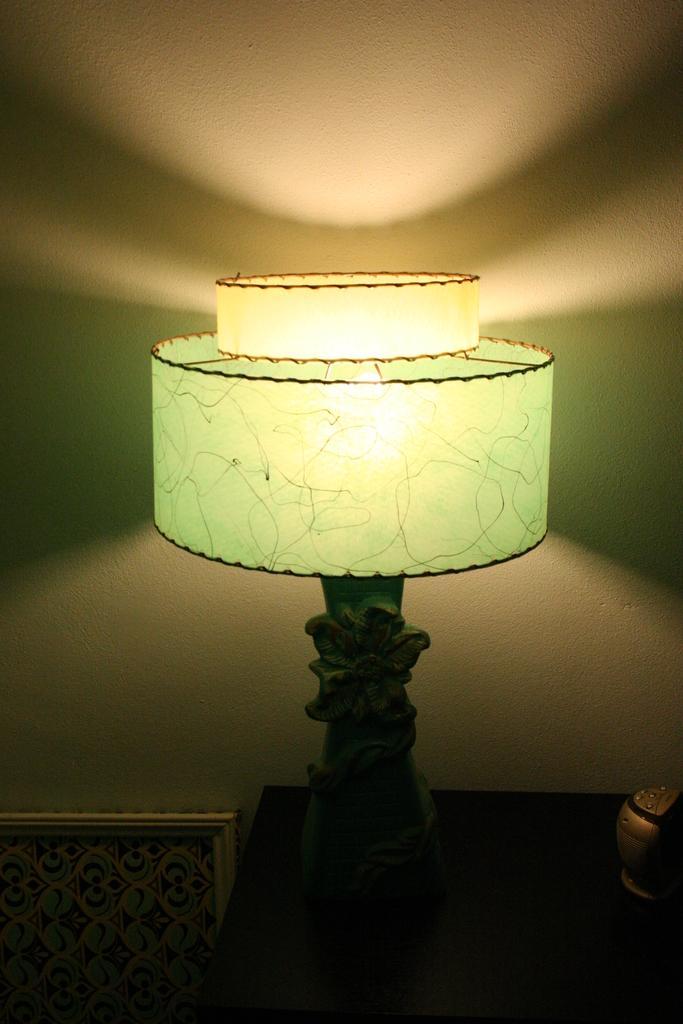In one or two sentences, can you explain what this image depicts? In this image we can see a lamp and a device placed on the table. In the left side of the image we can see a frame. At the top of the image we can see the wall. 